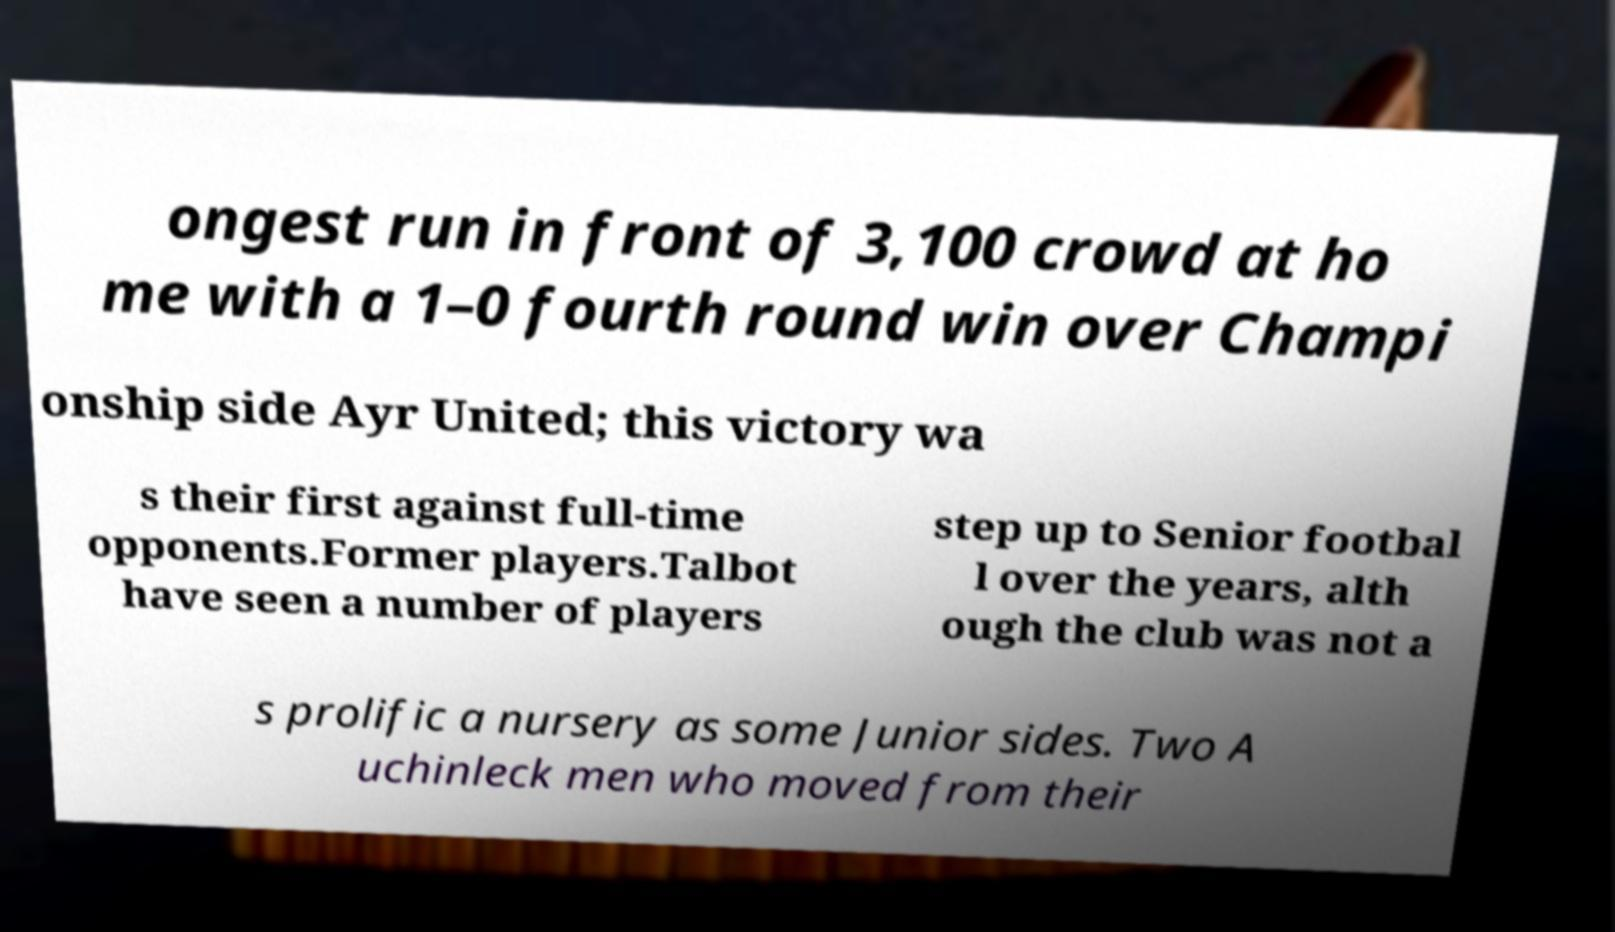There's text embedded in this image that I need extracted. Can you transcribe it verbatim? ongest run in front of 3,100 crowd at ho me with a 1–0 fourth round win over Champi onship side Ayr United; this victory wa s their first against full-time opponents.Former players.Talbot have seen a number of players step up to Senior footbal l over the years, alth ough the club was not a s prolific a nursery as some Junior sides. Two A uchinleck men who moved from their 